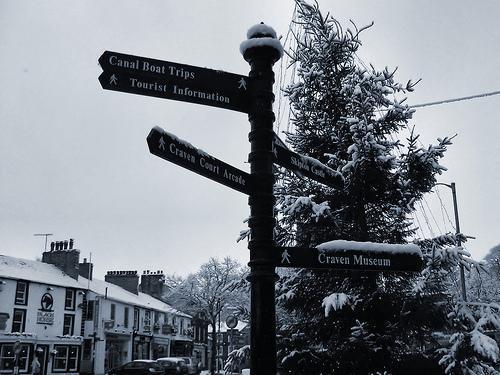How many signs are on the post ?
Give a very brief answer. 5. 